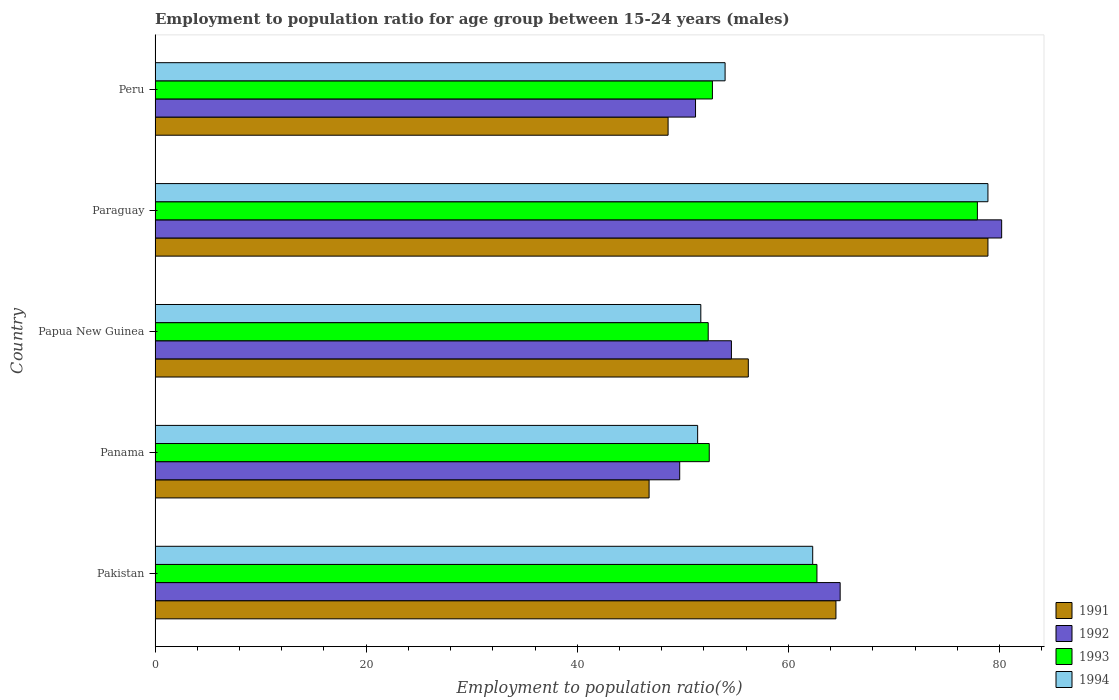How many groups of bars are there?
Make the answer very short. 5. Are the number of bars per tick equal to the number of legend labels?
Offer a terse response. Yes. How many bars are there on the 4th tick from the top?
Your answer should be compact. 4. What is the label of the 4th group of bars from the top?
Keep it short and to the point. Panama. In how many cases, is the number of bars for a given country not equal to the number of legend labels?
Offer a very short reply. 0. What is the employment to population ratio in 1993 in Peru?
Offer a terse response. 52.8. Across all countries, what is the maximum employment to population ratio in 1992?
Provide a succinct answer. 80.2. Across all countries, what is the minimum employment to population ratio in 1991?
Provide a succinct answer. 46.8. In which country was the employment to population ratio in 1993 maximum?
Keep it short and to the point. Paraguay. In which country was the employment to population ratio in 1993 minimum?
Your response must be concise. Papua New Guinea. What is the total employment to population ratio in 1992 in the graph?
Provide a succinct answer. 300.6. What is the difference between the employment to population ratio in 1993 in Panama and that in Papua New Guinea?
Your response must be concise. 0.1. What is the difference between the employment to population ratio in 1992 in Peru and the employment to population ratio in 1994 in Pakistan?
Give a very brief answer. -11.1. What is the average employment to population ratio in 1992 per country?
Give a very brief answer. 60.12. What is the difference between the employment to population ratio in 1993 and employment to population ratio in 1994 in Panama?
Offer a terse response. 1.1. What is the ratio of the employment to population ratio in 1992 in Panama to that in Papua New Guinea?
Give a very brief answer. 0.91. Is the difference between the employment to population ratio in 1993 in Panama and Papua New Guinea greater than the difference between the employment to population ratio in 1994 in Panama and Papua New Guinea?
Your answer should be compact. Yes. What is the difference between the highest and the second highest employment to population ratio in 1993?
Ensure brevity in your answer.  15.2. What is the difference between the highest and the lowest employment to population ratio in 1991?
Offer a very short reply. 32.1. In how many countries, is the employment to population ratio in 1993 greater than the average employment to population ratio in 1993 taken over all countries?
Your answer should be very brief. 2. Is the sum of the employment to population ratio in 1993 in Papua New Guinea and Peru greater than the maximum employment to population ratio in 1991 across all countries?
Provide a succinct answer. Yes. What does the 4th bar from the top in Panama represents?
Make the answer very short. 1991. How many bars are there?
Give a very brief answer. 20. Are all the bars in the graph horizontal?
Keep it short and to the point. Yes. Where does the legend appear in the graph?
Your answer should be very brief. Bottom right. How are the legend labels stacked?
Your answer should be compact. Vertical. What is the title of the graph?
Provide a succinct answer. Employment to population ratio for age group between 15-24 years (males). What is the label or title of the X-axis?
Your response must be concise. Employment to population ratio(%). What is the Employment to population ratio(%) in 1991 in Pakistan?
Give a very brief answer. 64.5. What is the Employment to population ratio(%) in 1992 in Pakistan?
Your answer should be very brief. 64.9. What is the Employment to population ratio(%) in 1993 in Pakistan?
Make the answer very short. 62.7. What is the Employment to population ratio(%) in 1994 in Pakistan?
Give a very brief answer. 62.3. What is the Employment to population ratio(%) of 1991 in Panama?
Offer a terse response. 46.8. What is the Employment to population ratio(%) of 1992 in Panama?
Make the answer very short. 49.7. What is the Employment to population ratio(%) in 1993 in Panama?
Your response must be concise. 52.5. What is the Employment to population ratio(%) of 1994 in Panama?
Ensure brevity in your answer.  51.4. What is the Employment to population ratio(%) in 1991 in Papua New Guinea?
Give a very brief answer. 56.2. What is the Employment to population ratio(%) in 1992 in Papua New Guinea?
Ensure brevity in your answer.  54.6. What is the Employment to population ratio(%) in 1993 in Papua New Guinea?
Your answer should be compact. 52.4. What is the Employment to population ratio(%) in 1994 in Papua New Guinea?
Give a very brief answer. 51.7. What is the Employment to population ratio(%) in 1991 in Paraguay?
Your response must be concise. 78.9. What is the Employment to population ratio(%) of 1992 in Paraguay?
Your answer should be compact. 80.2. What is the Employment to population ratio(%) of 1993 in Paraguay?
Offer a very short reply. 77.9. What is the Employment to population ratio(%) in 1994 in Paraguay?
Ensure brevity in your answer.  78.9. What is the Employment to population ratio(%) in 1991 in Peru?
Give a very brief answer. 48.6. What is the Employment to population ratio(%) of 1992 in Peru?
Your answer should be very brief. 51.2. What is the Employment to population ratio(%) in 1993 in Peru?
Give a very brief answer. 52.8. What is the Employment to population ratio(%) in 1994 in Peru?
Offer a very short reply. 54. Across all countries, what is the maximum Employment to population ratio(%) in 1991?
Provide a succinct answer. 78.9. Across all countries, what is the maximum Employment to population ratio(%) of 1992?
Offer a terse response. 80.2. Across all countries, what is the maximum Employment to population ratio(%) in 1993?
Make the answer very short. 77.9. Across all countries, what is the maximum Employment to population ratio(%) of 1994?
Ensure brevity in your answer.  78.9. Across all countries, what is the minimum Employment to population ratio(%) in 1991?
Make the answer very short. 46.8. Across all countries, what is the minimum Employment to population ratio(%) of 1992?
Give a very brief answer. 49.7. Across all countries, what is the minimum Employment to population ratio(%) of 1993?
Your answer should be compact. 52.4. Across all countries, what is the minimum Employment to population ratio(%) in 1994?
Offer a terse response. 51.4. What is the total Employment to population ratio(%) in 1991 in the graph?
Offer a terse response. 295. What is the total Employment to population ratio(%) in 1992 in the graph?
Give a very brief answer. 300.6. What is the total Employment to population ratio(%) of 1993 in the graph?
Your response must be concise. 298.3. What is the total Employment to population ratio(%) of 1994 in the graph?
Your answer should be very brief. 298.3. What is the difference between the Employment to population ratio(%) in 1991 in Pakistan and that in Panama?
Offer a very short reply. 17.7. What is the difference between the Employment to population ratio(%) in 1993 in Pakistan and that in Panama?
Keep it short and to the point. 10.2. What is the difference between the Employment to population ratio(%) in 1994 in Pakistan and that in Panama?
Your answer should be compact. 10.9. What is the difference between the Employment to population ratio(%) of 1992 in Pakistan and that in Papua New Guinea?
Your answer should be very brief. 10.3. What is the difference between the Employment to population ratio(%) of 1993 in Pakistan and that in Papua New Guinea?
Your answer should be compact. 10.3. What is the difference between the Employment to population ratio(%) in 1991 in Pakistan and that in Paraguay?
Your response must be concise. -14.4. What is the difference between the Employment to population ratio(%) of 1992 in Pakistan and that in Paraguay?
Your answer should be compact. -15.3. What is the difference between the Employment to population ratio(%) in 1993 in Pakistan and that in Paraguay?
Keep it short and to the point. -15.2. What is the difference between the Employment to population ratio(%) in 1994 in Pakistan and that in Paraguay?
Make the answer very short. -16.6. What is the difference between the Employment to population ratio(%) in 1991 in Pakistan and that in Peru?
Keep it short and to the point. 15.9. What is the difference between the Employment to population ratio(%) in 1993 in Pakistan and that in Peru?
Your answer should be very brief. 9.9. What is the difference between the Employment to population ratio(%) of 1994 in Panama and that in Papua New Guinea?
Provide a succinct answer. -0.3. What is the difference between the Employment to population ratio(%) in 1991 in Panama and that in Paraguay?
Provide a short and direct response. -32.1. What is the difference between the Employment to population ratio(%) in 1992 in Panama and that in Paraguay?
Offer a very short reply. -30.5. What is the difference between the Employment to population ratio(%) of 1993 in Panama and that in Paraguay?
Give a very brief answer. -25.4. What is the difference between the Employment to population ratio(%) in 1994 in Panama and that in Paraguay?
Ensure brevity in your answer.  -27.5. What is the difference between the Employment to population ratio(%) of 1991 in Panama and that in Peru?
Ensure brevity in your answer.  -1.8. What is the difference between the Employment to population ratio(%) of 1992 in Panama and that in Peru?
Give a very brief answer. -1.5. What is the difference between the Employment to population ratio(%) of 1994 in Panama and that in Peru?
Your answer should be compact. -2.6. What is the difference between the Employment to population ratio(%) in 1991 in Papua New Guinea and that in Paraguay?
Keep it short and to the point. -22.7. What is the difference between the Employment to population ratio(%) in 1992 in Papua New Guinea and that in Paraguay?
Provide a succinct answer. -25.6. What is the difference between the Employment to population ratio(%) in 1993 in Papua New Guinea and that in Paraguay?
Offer a terse response. -25.5. What is the difference between the Employment to population ratio(%) in 1994 in Papua New Guinea and that in Paraguay?
Ensure brevity in your answer.  -27.2. What is the difference between the Employment to population ratio(%) in 1993 in Papua New Guinea and that in Peru?
Offer a terse response. -0.4. What is the difference between the Employment to population ratio(%) in 1991 in Paraguay and that in Peru?
Provide a succinct answer. 30.3. What is the difference between the Employment to population ratio(%) of 1993 in Paraguay and that in Peru?
Offer a terse response. 25.1. What is the difference between the Employment to population ratio(%) of 1994 in Paraguay and that in Peru?
Provide a short and direct response. 24.9. What is the difference between the Employment to population ratio(%) in 1991 in Pakistan and the Employment to population ratio(%) in 1992 in Panama?
Offer a terse response. 14.8. What is the difference between the Employment to population ratio(%) in 1991 in Pakistan and the Employment to population ratio(%) in 1993 in Panama?
Give a very brief answer. 12. What is the difference between the Employment to population ratio(%) of 1993 in Pakistan and the Employment to population ratio(%) of 1994 in Panama?
Make the answer very short. 11.3. What is the difference between the Employment to population ratio(%) in 1991 in Pakistan and the Employment to population ratio(%) in 1992 in Papua New Guinea?
Your response must be concise. 9.9. What is the difference between the Employment to population ratio(%) in 1992 in Pakistan and the Employment to population ratio(%) in 1994 in Papua New Guinea?
Keep it short and to the point. 13.2. What is the difference between the Employment to population ratio(%) of 1993 in Pakistan and the Employment to population ratio(%) of 1994 in Papua New Guinea?
Give a very brief answer. 11. What is the difference between the Employment to population ratio(%) in 1991 in Pakistan and the Employment to population ratio(%) in 1992 in Paraguay?
Keep it short and to the point. -15.7. What is the difference between the Employment to population ratio(%) in 1991 in Pakistan and the Employment to population ratio(%) in 1993 in Paraguay?
Give a very brief answer. -13.4. What is the difference between the Employment to population ratio(%) in 1991 in Pakistan and the Employment to population ratio(%) in 1994 in Paraguay?
Offer a very short reply. -14.4. What is the difference between the Employment to population ratio(%) in 1992 in Pakistan and the Employment to population ratio(%) in 1994 in Paraguay?
Offer a very short reply. -14. What is the difference between the Employment to population ratio(%) of 1993 in Pakistan and the Employment to population ratio(%) of 1994 in Paraguay?
Offer a very short reply. -16.2. What is the difference between the Employment to population ratio(%) of 1991 in Pakistan and the Employment to population ratio(%) of 1992 in Peru?
Your response must be concise. 13.3. What is the difference between the Employment to population ratio(%) in 1991 in Pakistan and the Employment to population ratio(%) in 1993 in Peru?
Ensure brevity in your answer.  11.7. What is the difference between the Employment to population ratio(%) of 1992 in Pakistan and the Employment to population ratio(%) of 1993 in Peru?
Your answer should be very brief. 12.1. What is the difference between the Employment to population ratio(%) in 1993 in Pakistan and the Employment to population ratio(%) in 1994 in Peru?
Make the answer very short. 8.7. What is the difference between the Employment to population ratio(%) in 1991 in Panama and the Employment to population ratio(%) in 1993 in Papua New Guinea?
Your answer should be compact. -5.6. What is the difference between the Employment to population ratio(%) in 1991 in Panama and the Employment to population ratio(%) in 1994 in Papua New Guinea?
Provide a short and direct response. -4.9. What is the difference between the Employment to population ratio(%) of 1991 in Panama and the Employment to population ratio(%) of 1992 in Paraguay?
Provide a succinct answer. -33.4. What is the difference between the Employment to population ratio(%) in 1991 in Panama and the Employment to population ratio(%) in 1993 in Paraguay?
Ensure brevity in your answer.  -31.1. What is the difference between the Employment to population ratio(%) of 1991 in Panama and the Employment to population ratio(%) of 1994 in Paraguay?
Offer a very short reply. -32.1. What is the difference between the Employment to population ratio(%) of 1992 in Panama and the Employment to population ratio(%) of 1993 in Paraguay?
Keep it short and to the point. -28.2. What is the difference between the Employment to population ratio(%) of 1992 in Panama and the Employment to population ratio(%) of 1994 in Paraguay?
Offer a terse response. -29.2. What is the difference between the Employment to population ratio(%) of 1993 in Panama and the Employment to population ratio(%) of 1994 in Paraguay?
Your answer should be very brief. -26.4. What is the difference between the Employment to population ratio(%) of 1991 in Panama and the Employment to population ratio(%) of 1994 in Peru?
Give a very brief answer. -7.2. What is the difference between the Employment to population ratio(%) of 1993 in Panama and the Employment to population ratio(%) of 1994 in Peru?
Provide a succinct answer. -1.5. What is the difference between the Employment to population ratio(%) in 1991 in Papua New Guinea and the Employment to population ratio(%) in 1993 in Paraguay?
Keep it short and to the point. -21.7. What is the difference between the Employment to population ratio(%) of 1991 in Papua New Guinea and the Employment to population ratio(%) of 1994 in Paraguay?
Your answer should be very brief. -22.7. What is the difference between the Employment to population ratio(%) of 1992 in Papua New Guinea and the Employment to population ratio(%) of 1993 in Paraguay?
Keep it short and to the point. -23.3. What is the difference between the Employment to population ratio(%) in 1992 in Papua New Guinea and the Employment to population ratio(%) in 1994 in Paraguay?
Your response must be concise. -24.3. What is the difference between the Employment to population ratio(%) in 1993 in Papua New Guinea and the Employment to population ratio(%) in 1994 in Paraguay?
Ensure brevity in your answer.  -26.5. What is the difference between the Employment to population ratio(%) in 1991 in Papua New Guinea and the Employment to population ratio(%) in 1992 in Peru?
Make the answer very short. 5. What is the difference between the Employment to population ratio(%) in 1992 in Papua New Guinea and the Employment to population ratio(%) in 1993 in Peru?
Offer a very short reply. 1.8. What is the difference between the Employment to population ratio(%) in 1993 in Papua New Guinea and the Employment to population ratio(%) in 1994 in Peru?
Offer a terse response. -1.6. What is the difference between the Employment to population ratio(%) of 1991 in Paraguay and the Employment to population ratio(%) of 1992 in Peru?
Your answer should be very brief. 27.7. What is the difference between the Employment to population ratio(%) in 1991 in Paraguay and the Employment to population ratio(%) in 1993 in Peru?
Your response must be concise. 26.1. What is the difference between the Employment to population ratio(%) in 1991 in Paraguay and the Employment to population ratio(%) in 1994 in Peru?
Your response must be concise. 24.9. What is the difference between the Employment to population ratio(%) of 1992 in Paraguay and the Employment to population ratio(%) of 1993 in Peru?
Offer a very short reply. 27.4. What is the difference between the Employment to population ratio(%) in 1992 in Paraguay and the Employment to population ratio(%) in 1994 in Peru?
Offer a very short reply. 26.2. What is the difference between the Employment to population ratio(%) in 1993 in Paraguay and the Employment to population ratio(%) in 1994 in Peru?
Give a very brief answer. 23.9. What is the average Employment to population ratio(%) in 1992 per country?
Ensure brevity in your answer.  60.12. What is the average Employment to population ratio(%) of 1993 per country?
Your response must be concise. 59.66. What is the average Employment to population ratio(%) of 1994 per country?
Provide a succinct answer. 59.66. What is the difference between the Employment to population ratio(%) of 1991 and Employment to population ratio(%) of 1993 in Pakistan?
Your answer should be very brief. 1.8. What is the difference between the Employment to population ratio(%) of 1992 and Employment to population ratio(%) of 1993 in Pakistan?
Make the answer very short. 2.2. What is the difference between the Employment to population ratio(%) in 1992 and Employment to population ratio(%) in 1994 in Pakistan?
Provide a short and direct response. 2.6. What is the difference between the Employment to population ratio(%) of 1993 and Employment to population ratio(%) of 1994 in Pakistan?
Give a very brief answer. 0.4. What is the difference between the Employment to population ratio(%) in 1991 and Employment to population ratio(%) in 1992 in Panama?
Your answer should be very brief. -2.9. What is the difference between the Employment to population ratio(%) in 1991 and Employment to population ratio(%) in 1994 in Panama?
Provide a short and direct response. -4.6. What is the difference between the Employment to population ratio(%) of 1992 and Employment to population ratio(%) of 1993 in Panama?
Keep it short and to the point. -2.8. What is the difference between the Employment to population ratio(%) in 1992 and Employment to population ratio(%) in 1994 in Panama?
Keep it short and to the point. -1.7. What is the difference between the Employment to population ratio(%) in 1991 and Employment to population ratio(%) in 1992 in Papua New Guinea?
Your response must be concise. 1.6. What is the difference between the Employment to population ratio(%) of 1992 and Employment to population ratio(%) of 1993 in Papua New Guinea?
Keep it short and to the point. 2.2. What is the difference between the Employment to population ratio(%) in 1993 and Employment to population ratio(%) in 1994 in Papua New Guinea?
Ensure brevity in your answer.  0.7. What is the difference between the Employment to population ratio(%) of 1991 and Employment to population ratio(%) of 1992 in Paraguay?
Your answer should be very brief. -1.3. What is the difference between the Employment to population ratio(%) of 1991 and Employment to population ratio(%) of 1993 in Paraguay?
Make the answer very short. 1. What is the difference between the Employment to population ratio(%) in 1991 and Employment to population ratio(%) in 1994 in Paraguay?
Offer a terse response. 0. What is the difference between the Employment to population ratio(%) of 1992 and Employment to population ratio(%) of 1993 in Paraguay?
Make the answer very short. 2.3. What is the difference between the Employment to population ratio(%) of 1991 and Employment to population ratio(%) of 1992 in Peru?
Your response must be concise. -2.6. What is the difference between the Employment to population ratio(%) in 1991 and Employment to population ratio(%) in 1994 in Peru?
Offer a very short reply. -5.4. What is the difference between the Employment to population ratio(%) of 1992 and Employment to population ratio(%) of 1993 in Peru?
Keep it short and to the point. -1.6. What is the difference between the Employment to population ratio(%) of 1992 and Employment to population ratio(%) of 1994 in Peru?
Ensure brevity in your answer.  -2.8. What is the difference between the Employment to population ratio(%) of 1993 and Employment to population ratio(%) of 1994 in Peru?
Give a very brief answer. -1.2. What is the ratio of the Employment to population ratio(%) in 1991 in Pakistan to that in Panama?
Your response must be concise. 1.38. What is the ratio of the Employment to population ratio(%) of 1992 in Pakistan to that in Panama?
Your answer should be very brief. 1.31. What is the ratio of the Employment to population ratio(%) in 1993 in Pakistan to that in Panama?
Your answer should be very brief. 1.19. What is the ratio of the Employment to population ratio(%) in 1994 in Pakistan to that in Panama?
Offer a terse response. 1.21. What is the ratio of the Employment to population ratio(%) in 1991 in Pakistan to that in Papua New Guinea?
Give a very brief answer. 1.15. What is the ratio of the Employment to population ratio(%) of 1992 in Pakistan to that in Papua New Guinea?
Your answer should be compact. 1.19. What is the ratio of the Employment to population ratio(%) in 1993 in Pakistan to that in Papua New Guinea?
Offer a very short reply. 1.2. What is the ratio of the Employment to population ratio(%) of 1994 in Pakistan to that in Papua New Guinea?
Offer a very short reply. 1.21. What is the ratio of the Employment to population ratio(%) in 1991 in Pakistan to that in Paraguay?
Your answer should be compact. 0.82. What is the ratio of the Employment to population ratio(%) of 1992 in Pakistan to that in Paraguay?
Offer a very short reply. 0.81. What is the ratio of the Employment to population ratio(%) in 1993 in Pakistan to that in Paraguay?
Your answer should be very brief. 0.8. What is the ratio of the Employment to population ratio(%) of 1994 in Pakistan to that in Paraguay?
Keep it short and to the point. 0.79. What is the ratio of the Employment to population ratio(%) of 1991 in Pakistan to that in Peru?
Offer a very short reply. 1.33. What is the ratio of the Employment to population ratio(%) of 1992 in Pakistan to that in Peru?
Your answer should be very brief. 1.27. What is the ratio of the Employment to population ratio(%) in 1993 in Pakistan to that in Peru?
Your response must be concise. 1.19. What is the ratio of the Employment to population ratio(%) in 1994 in Pakistan to that in Peru?
Your answer should be very brief. 1.15. What is the ratio of the Employment to population ratio(%) of 1991 in Panama to that in Papua New Guinea?
Provide a short and direct response. 0.83. What is the ratio of the Employment to population ratio(%) of 1992 in Panama to that in Papua New Guinea?
Your response must be concise. 0.91. What is the ratio of the Employment to population ratio(%) in 1993 in Panama to that in Papua New Guinea?
Give a very brief answer. 1. What is the ratio of the Employment to population ratio(%) in 1994 in Panama to that in Papua New Guinea?
Offer a terse response. 0.99. What is the ratio of the Employment to population ratio(%) of 1991 in Panama to that in Paraguay?
Offer a very short reply. 0.59. What is the ratio of the Employment to population ratio(%) of 1992 in Panama to that in Paraguay?
Provide a succinct answer. 0.62. What is the ratio of the Employment to population ratio(%) of 1993 in Panama to that in Paraguay?
Provide a short and direct response. 0.67. What is the ratio of the Employment to population ratio(%) of 1994 in Panama to that in Paraguay?
Offer a terse response. 0.65. What is the ratio of the Employment to population ratio(%) of 1991 in Panama to that in Peru?
Offer a terse response. 0.96. What is the ratio of the Employment to population ratio(%) in 1992 in Panama to that in Peru?
Your answer should be compact. 0.97. What is the ratio of the Employment to population ratio(%) of 1994 in Panama to that in Peru?
Give a very brief answer. 0.95. What is the ratio of the Employment to population ratio(%) in 1991 in Papua New Guinea to that in Paraguay?
Give a very brief answer. 0.71. What is the ratio of the Employment to population ratio(%) in 1992 in Papua New Guinea to that in Paraguay?
Make the answer very short. 0.68. What is the ratio of the Employment to population ratio(%) in 1993 in Papua New Guinea to that in Paraguay?
Make the answer very short. 0.67. What is the ratio of the Employment to population ratio(%) in 1994 in Papua New Guinea to that in Paraguay?
Offer a terse response. 0.66. What is the ratio of the Employment to population ratio(%) in 1991 in Papua New Guinea to that in Peru?
Offer a terse response. 1.16. What is the ratio of the Employment to population ratio(%) of 1992 in Papua New Guinea to that in Peru?
Make the answer very short. 1.07. What is the ratio of the Employment to population ratio(%) in 1993 in Papua New Guinea to that in Peru?
Your answer should be compact. 0.99. What is the ratio of the Employment to population ratio(%) in 1994 in Papua New Guinea to that in Peru?
Provide a succinct answer. 0.96. What is the ratio of the Employment to population ratio(%) in 1991 in Paraguay to that in Peru?
Your answer should be compact. 1.62. What is the ratio of the Employment to population ratio(%) in 1992 in Paraguay to that in Peru?
Your response must be concise. 1.57. What is the ratio of the Employment to population ratio(%) of 1993 in Paraguay to that in Peru?
Keep it short and to the point. 1.48. What is the ratio of the Employment to population ratio(%) in 1994 in Paraguay to that in Peru?
Offer a terse response. 1.46. What is the difference between the highest and the second highest Employment to population ratio(%) of 1991?
Make the answer very short. 14.4. What is the difference between the highest and the second highest Employment to population ratio(%) in 1992?
Provide a succinct answer. 15.3. What is the difference between the highest and the second highest Employment to population ratio(%) in 1993?
Keep it short and to the point. 15.2. What is the difference between the highest and the lowest Employment to population ratio(%) of 1991?
Give a very brief answer. 32.1. What is the difference between the highest and the lowest Employment to population ratio(%) in 1992?
Make the answer very short. 30.5. What is the difference between the highest and the lowest Employment to population ratio(%) in 1994?
Keep it short and to the point. 27.5. 